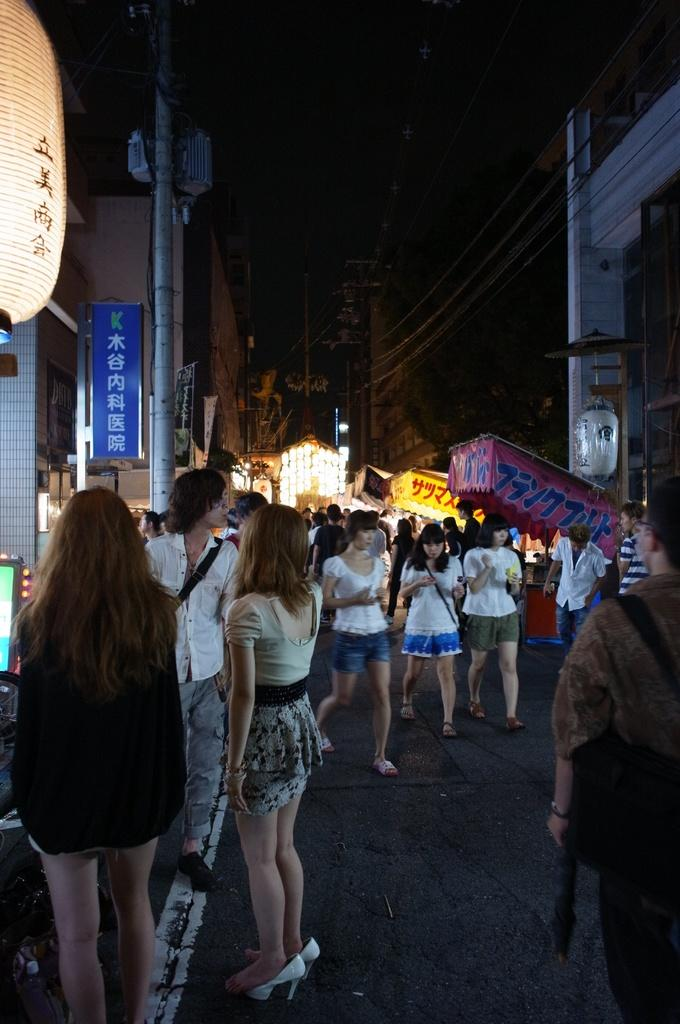What is happening in the foreground of the image? In the foreground, there is a crowd on the road, shops, boards, light poles, a lamp, buildings, and wires. Can you describe the objects in the foreground? The foreground features a crowd, shops, boards, light poles, a lamp, buildings, and wires. What is the condition of the sky in the image? The sky is visible at the top of the image, and it may have been taken during the night. Where can the basket of lettuce be seen in the image? There is no basket of lettuce present in the image. What type of heat source is visible in the image? There is no heat source visible in the image. 